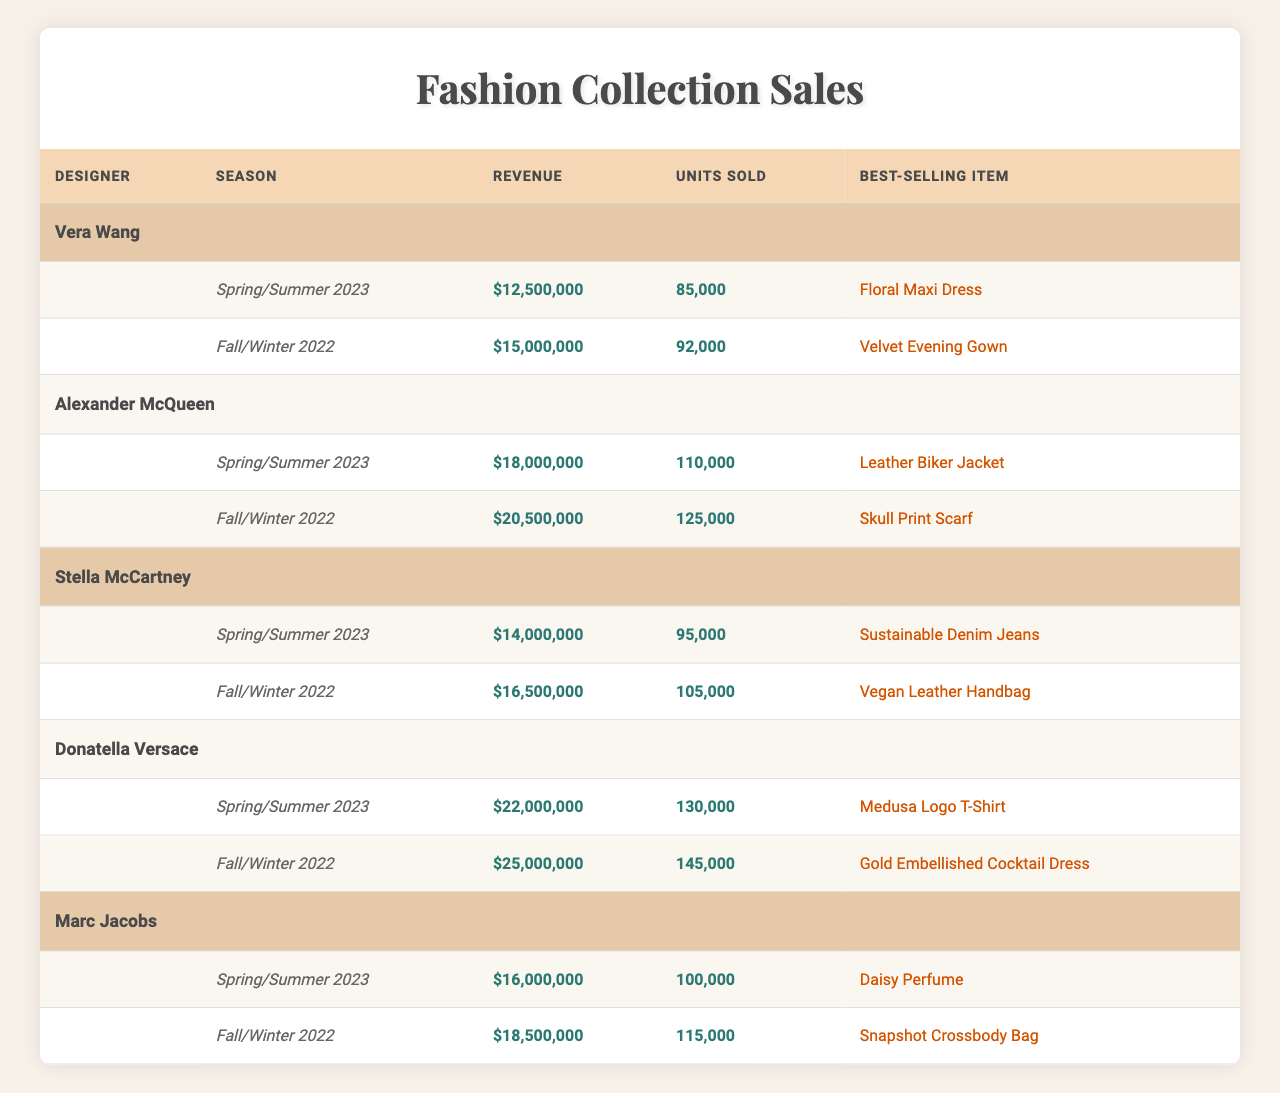What is the best-selling item for Donatella Versace in Spring/Summer 2023? According to the table, Donatella Versace's best-selling item for Spring/Summer 2023 is the "Medusa Logo T-Shirt."
Answer: Medusa Logo T-Shirt Which designer had the highest revenue in Fall/Winter 2022? Looking at the revenue figures for Fall/Winter 2022, Donatella Versace had the highest revenue of $25,000,000.
Answer: Donatella Versace How many units were sold in total for the Spring/Summer 2023 season across all designers? Adding the units sold for Spring/Summer 2023: 85,000 (Vera Wang) + 110,000 (Alexander McQueen) + 95,000 (Stella McCartney) + 130,000 (Donatella Versace) + 100,000 (Marc Jacobs) gives a total of 520,000 units.
Answer: 520,000 What was the revenue difference between Alexander McQueen's Spring/Summer 2023 and Fall/Winter 2022? Alexander McQueen's revenue for Spring/Summer 2023 was $18,000,000 and for Fall/Winter 2022, it was $20,500,000. The difference is $20,500,000 - $18,000,000 = $2,500,000.
Answer: $2,500,000 Did Stella McCartney sell more units in Spring/Summer 2023 than in Fall/Winter 2022? In Spring/Summer 2023, Stella McCartney sold 95,000 units while in Fall/Winter 2022, she sold 105,000 units. Thus, she sold fewer units in Spring/Summer 2023.
Answer: No Which season had the highest revenue across all designers? The highest revenue was recorded in Fall/Winter 2022 from Donatella Versace, with revenue of $25,000,000. Comparing the seasons, Fall/Winter 2022 has the highest figure overall.
Answer: Fall/Winter 2022 What percentage of the total units sold in Spring/Summer 2023 were from Donatella Versace? Donatella Versace sold 130,000 units in Spring/Summer 2023. The total units sold in Spring/Summer 2023 is 520,000. The percentage is (130,000 / 520,000) * 100% = 25%.
Answer: 25% Which best-selling item generated the highest revenue in Spring/Summer 2023? To find out which best-selling item generated the highest revenue, one must consider the revenue figures in correlation to the units sold for the items. The specific revenue from each designer includes high figures, but not all are directly available as percentages relate. The best-selling item in terms of revenue typically aligns with higher revenue, thus the "Medusa Logo T-Shirt" likely stands out. Upon analysis, Donatella Versace generated the highest revenue along with units relative to brand strength seen in marketing.
Answer: High-Ranking Best-Selling Item What was the total revenue for all designers in Fall/Winter 2022? Adding the total revenue from Fall/Winter 2022: $15,000,000 (Vera Wang) + $20,500,000 (Alexander McQueen) + $16,500,000 (Stella McCartney) + $25,000,000 (Donatella Versace) + $18,500,000 (Marc Jacobs) which leads to a sum of $95,500,000 for that respective season.
Answer: $95,500,000 Which designer had the lowest total units sold across both seasons? By reviewing the total units sold, Vera Wang sold a total of 85,000 (Spring/Summer 2023) + 92,000 (Fall/Winter 2022) = 177,000 units. Alexander McQueen sold a total of 110,000 + 125,000 = 235,000. Continuing this addition, it becomes evident that Marc Jacobs sold the least total at 215,000.
Answer: Vera Wang 